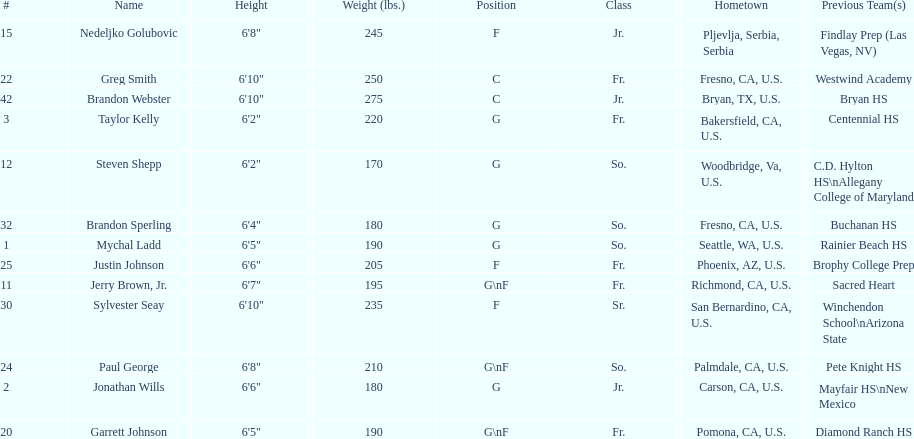What are the listed classes of the players? So., Jr., Fr., Fr., So., Jr., Fr., Fr., So., Fr., Sr., So., Jr. Which of these is not from the us? Jr. To which name does that entry correspond to? Nedeljko Golubovic. 